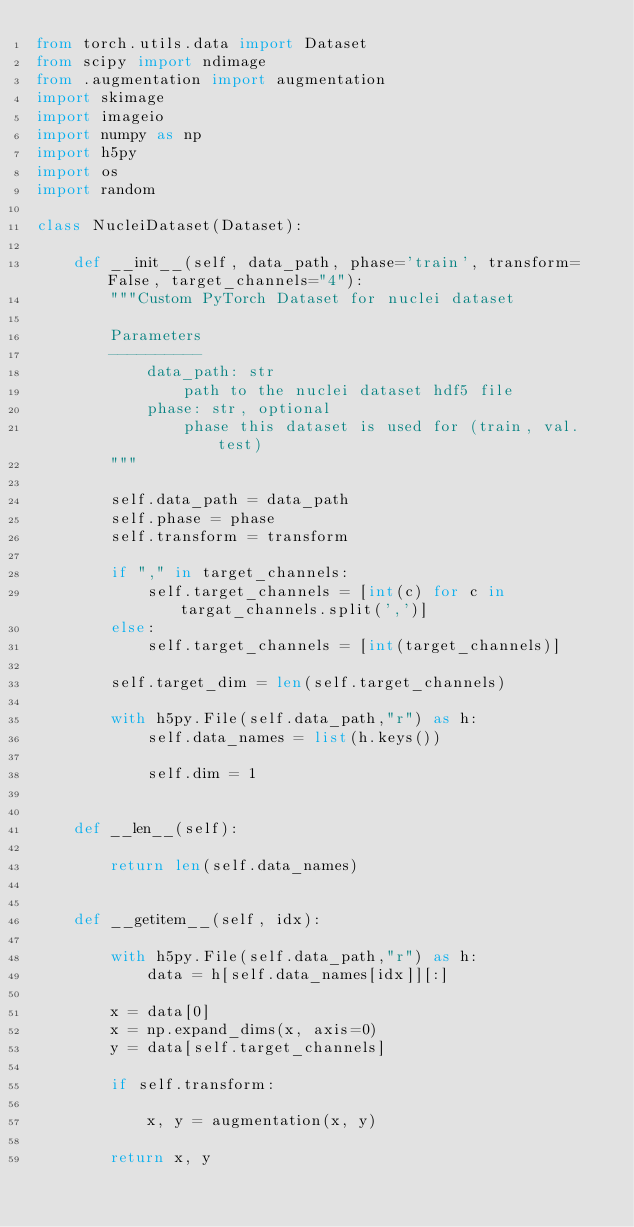Convert code to text. <code><loc_0><loc_0><loc_500><loc_500><_Python_>from torch.utils.data import Dataset
from scipy import ndimage
from .augmentation import augmentation
import skimage
import imageio
import numpy as np
import h5py
import os
import random

class NucleiDataset(Dataset):

    def __init__(self, data_path, phase='train', transform=False, target_channels="4"):
        """Custom PyTorch Dataset for nuclei dataset

        Parameters
        ----------
            data_path: str
                path to the nuclei dataset hdf5 file
            phase: str, optional
                phase this dataset is used for (train, val. test)
        """

        self.data_path = data_path
        self.phase = phase
        self.transform = transform
        
        if "," in target_channels: 
            self.target_channels = [int(c) for c in targat_channels.split(',')]
        else:
            self.target_channels = [int(target_channels)]

        self.target_dim = len(self.target_channels)

        with h5py.File(self.data_path,"r") as h:
            self.data_names = list(h.keys())

            self.dim = 1    


    def __len__(self):

        return len(self.data_names)


    def __getitem__(self, idx):

        with h5py.File(self.data_path,"r") as h:
            data = h[self.data_names[idx]][:]

        x = data[0]
        x = np.expand_dims(x, axis=0)
        y = data[self.target_channels]

        if self.transform:

            x, y = augmentation(x, y)

        return x, y
</code> 